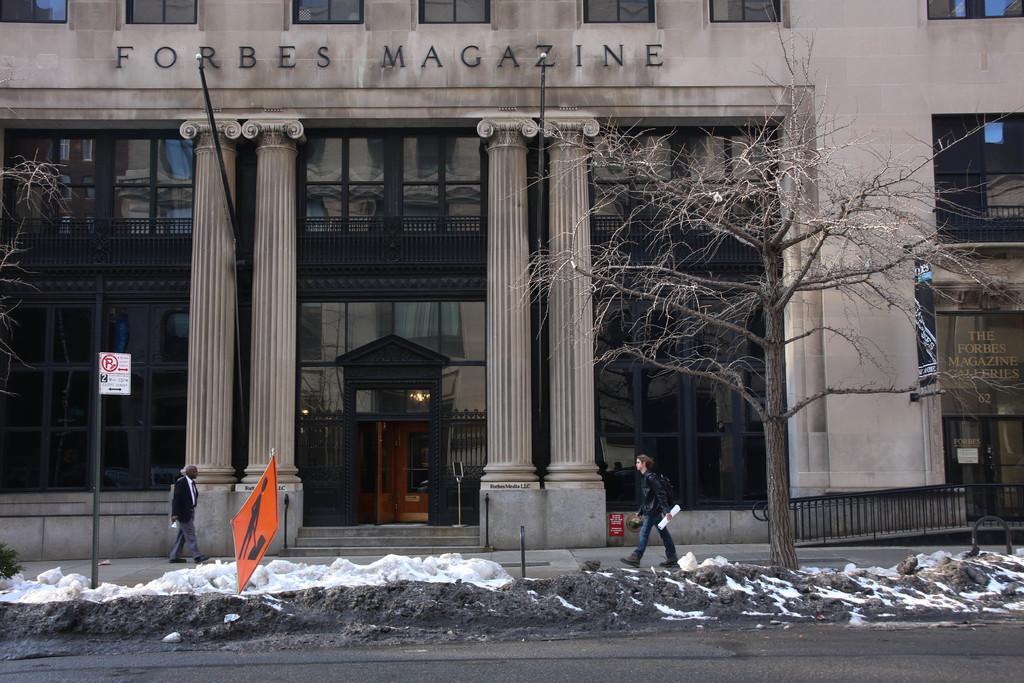Please provide a concise description of this image. In this image two persons are walking on the pavement. There is some snow on the land giving tree. Left side there is a pole having a board attached to it. Background there is a building. Bottom of the image there is road. Left side there is a tree. Right side there is a fence. 